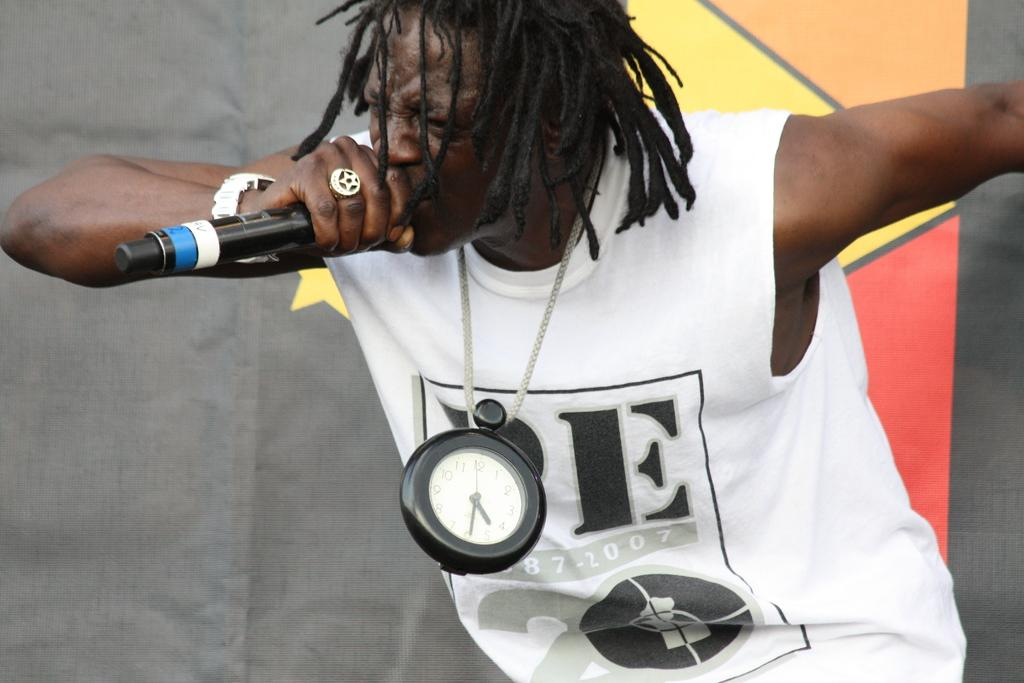<image>
Write a terse but informative summary of the picture. a shirt that has the letters oe on it 